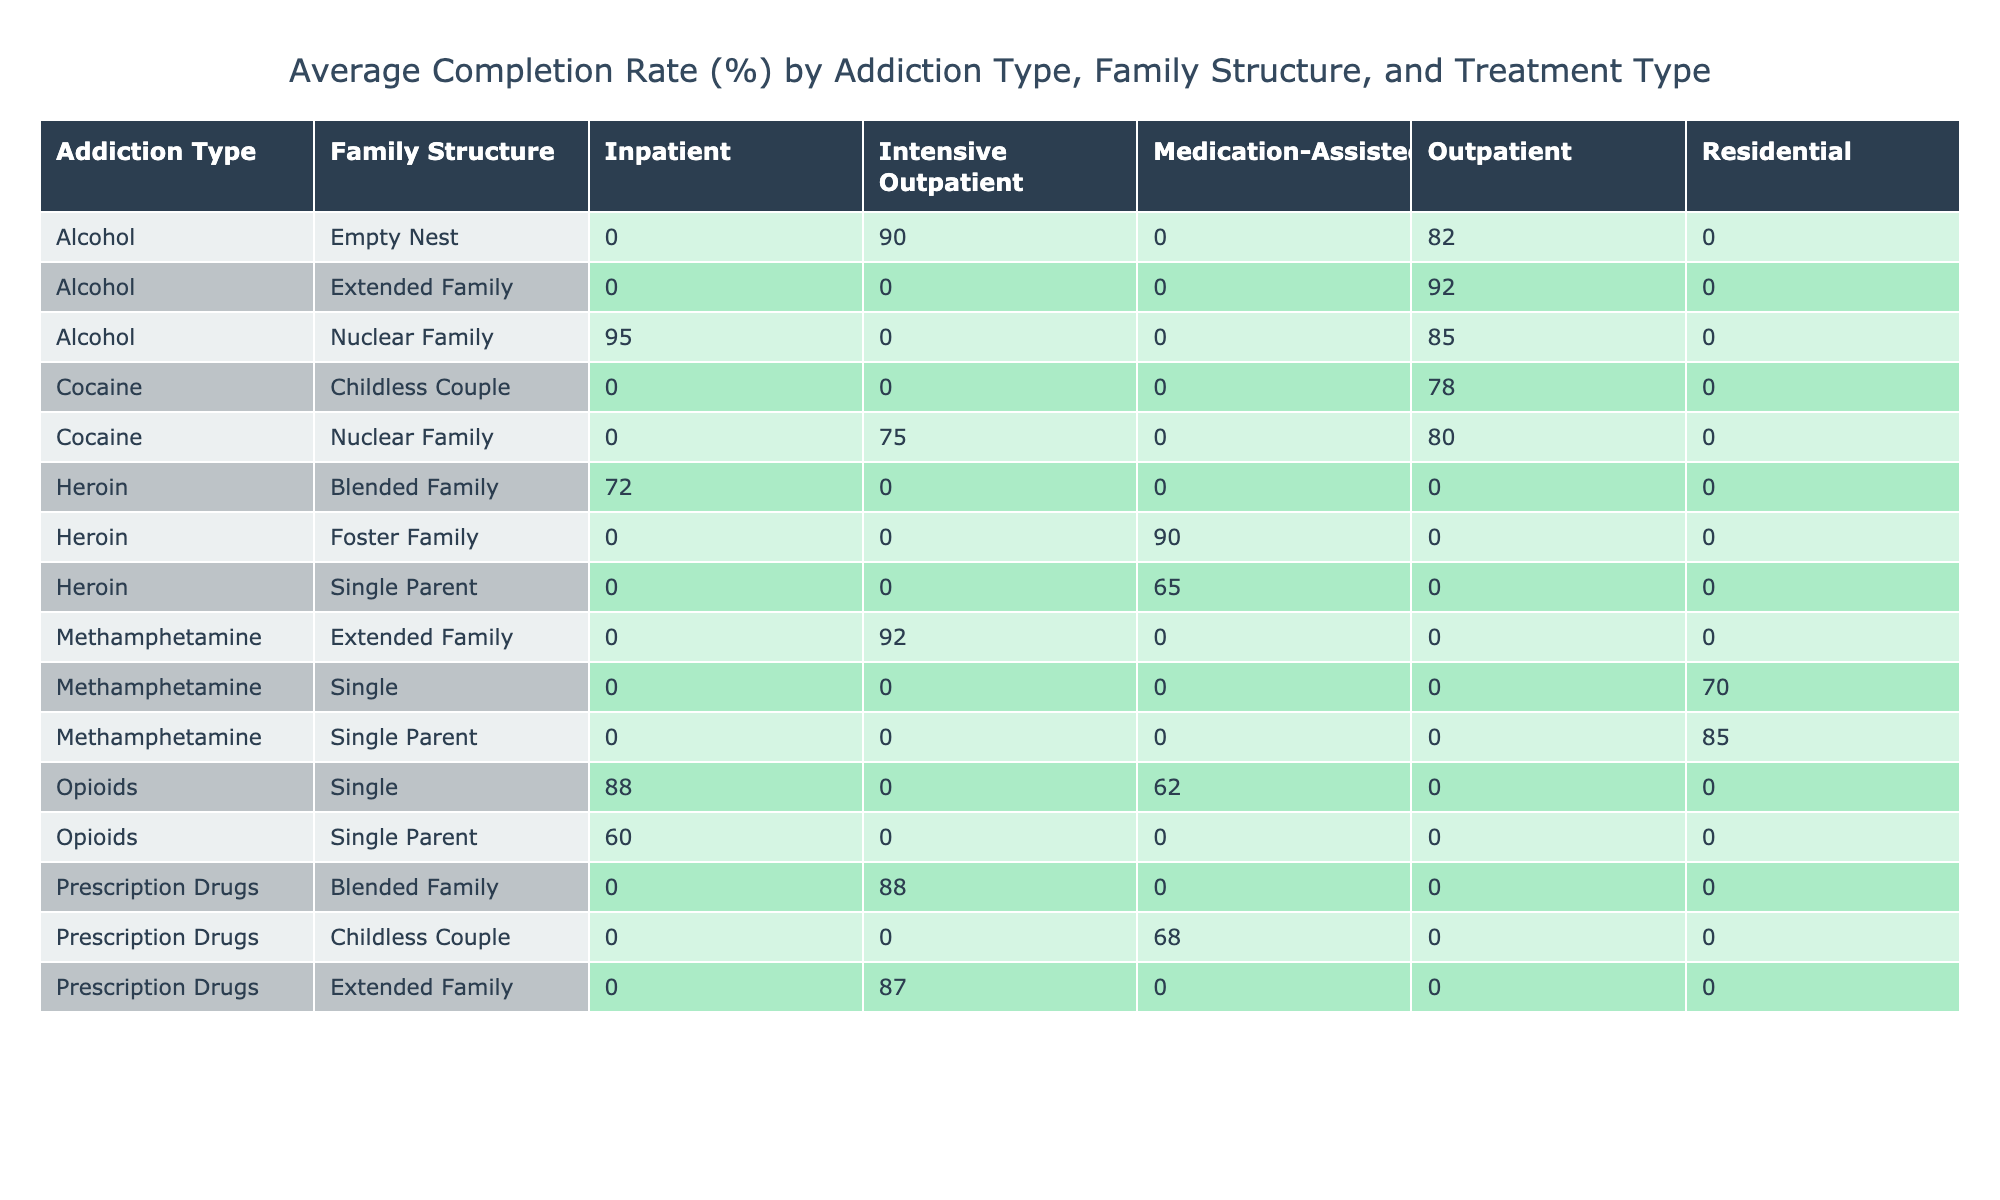What's the average completion rate for Alcohol addiction in a Nuclear Family structure? To find this, we look at the table for Alcohol under the Nuclear Family. The average completion rate for this category is calculated by looking at the Outpatient and Inpatient treatment types: (85 + 95) / 2 = 90.
Answer: 90 What is the highest average completion rate for any addiction type across all family structures? We can visually scan the table for the highest values in the completion rates across all addiction types. The highest value is for Alcohol in the Inpatient category, which shows a 95% completion rate.
Answer: 95% Are there any addiction types that have a 100% completion rate? By examining the table, we can see that no completion rate reaches 100% for any addiction type across different family structures.
Answer: No What is the average completion rate for Heroin treatment overall? We need to find all completion rates for Heroin across the different family structures (90, 65, 72, and 85, for medication-assisted). We sum them: (90 + 65 + 72 + 85) and divide by 4, giving (312 / 4) = 78.
Answer: 78 Is there a significant difference in completion rates between Inpatient and Outpatient treatment types for Cocaine addiction? For Cocaine addiction, the completion rates are 75% (Inpatient) and 80% (Outpatient). The difference is calculated as 80 - 75 = 5%. The difference is not significant; both rates are relatively close.
Answer: 5% difference Which family structure has the highest average completion rate across all addiction types? To find this, we need to sum the completion rates per family structure and divide by the number of entries. After calculating, the Extended Family structure has the highest average completion rate of (87 + 92 + 90)/3 = 89.67.
Answer: 89.67 What proportion of patients with Mental Health Comorbidity completed their treatment successfully? First, we identify patients with Mental Health Comorbidity from the table. Then, we count how many completed their treatment successfully (Depression and PTSD have completion rates of 85, 90, 92) and find the successful ones (3 out of 6). Therefore, the proportion is 3/6 = 50%.
Answer: 50% Is there any family structure that consistently shows low completion rates regardless of addiction type? By closely inspecting the table, we note that the Single Parent structure has a lower average completion rate (categories show completion rates 60, 65, 62)—significant drop compared to others.
Answer: Yes, Single Parent shows consistently low rates 